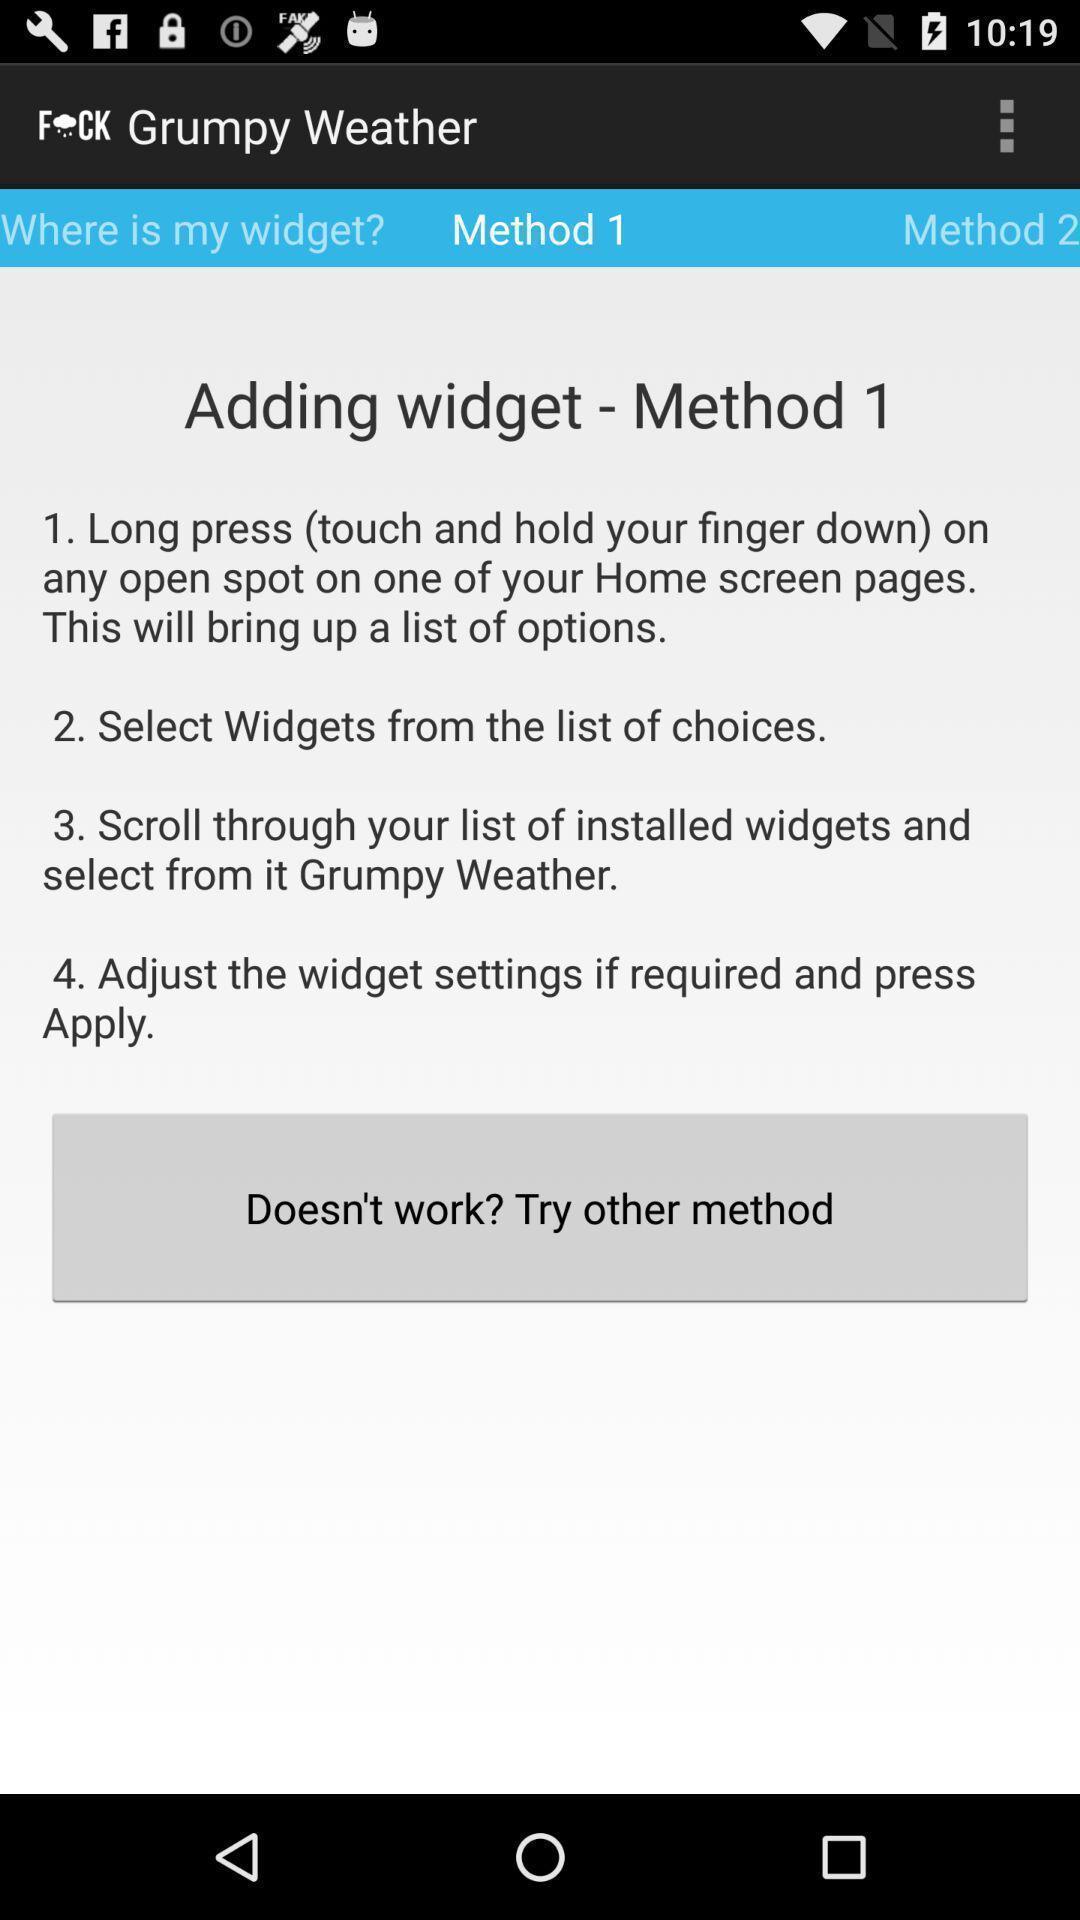What is the overall content of this screenshot? Page displaying methods of adding widget. 